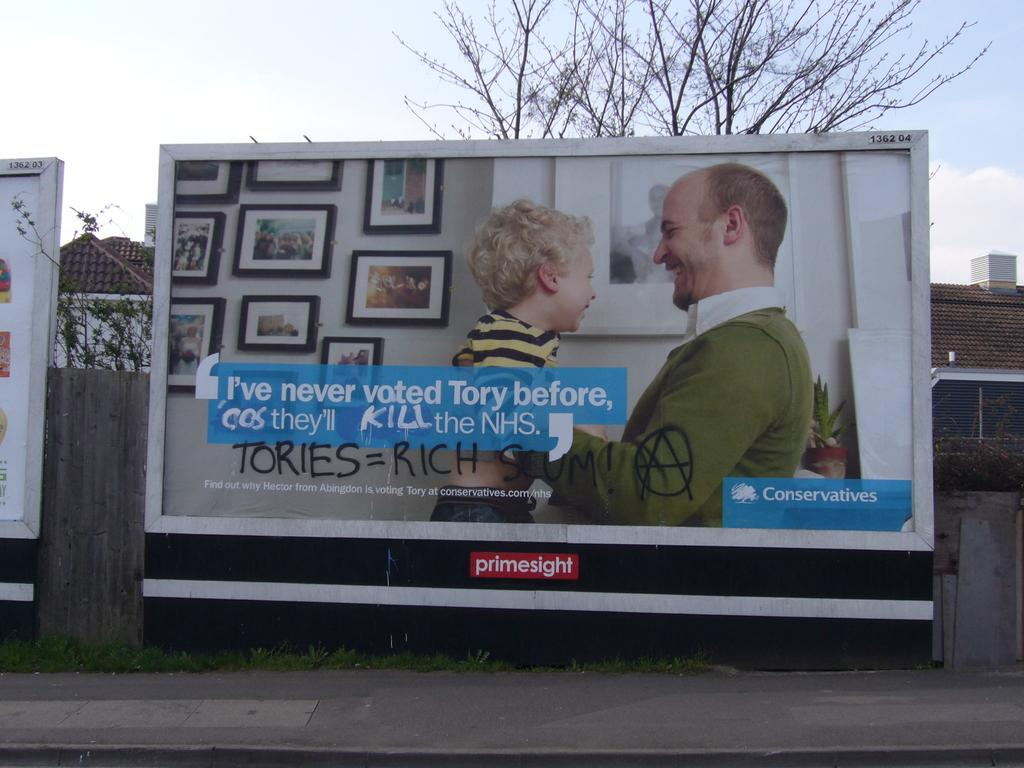What is the main subject in the middle of the image? There is a hoarding in the middle of the image. What can be seen behind the hoarding? There are trees and buildings behind the hoarding. What is visible at the top of the image? Clouds and the sky are visible at the top of the image. Can you see a pig on the hoarding in the image? There is no pig present on the hoarding in the image. What time is displayed on the clock on the hoarding in the image? There is no clock present on the hoarding in the image. 